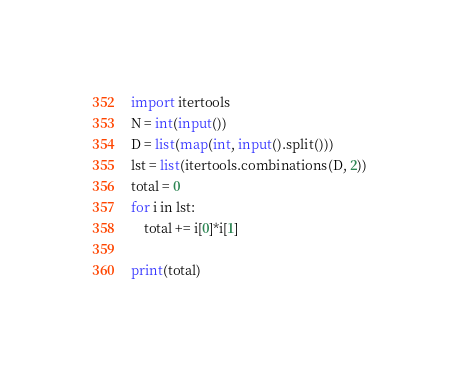Convert code to text. <code><loc_0><loc_0><loc_500><loc_500><_Python_>import itertools
N = int(input())
D = list(map(int, input().split()))
lst = list(itertools.combinations(D, 2))
total = 0
for i in lst:
    total += i[0]*i[1]

print(total)</code> 